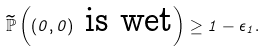<formula> <loc_0><loc_0><loc_500><loc_500>\widetilde { \mathbb { P } } \left ( ( 0 , 0 ) \text { is wet} \right ) \geq 1 - \epsilon _ { 1 } .</formula> 